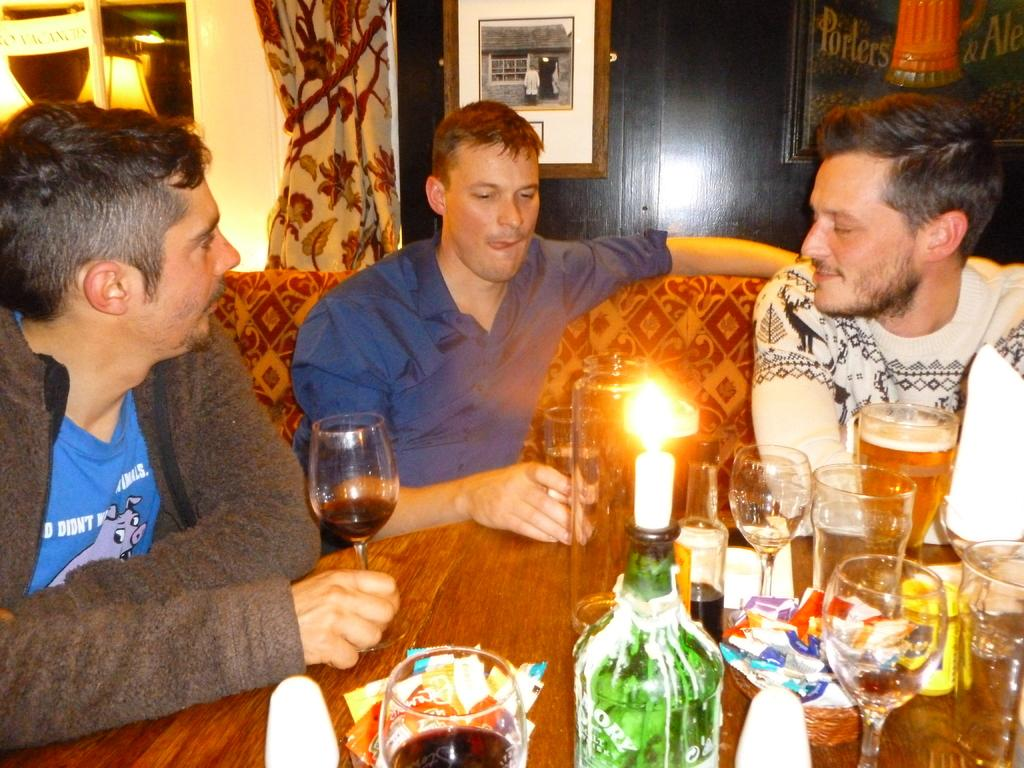How many people are sitting on the sofa in the image? There are three people sitting on the sofa in the image. What is located in front of the sofa? There is a table in front of the sofa. What can be seen on the table in the image? There are many items on the table. Is there a bomb hidden under the sofa in the image? There is no mention of a bomb or any hidden objects in the image, so we cannot confirm or deny its presence. 